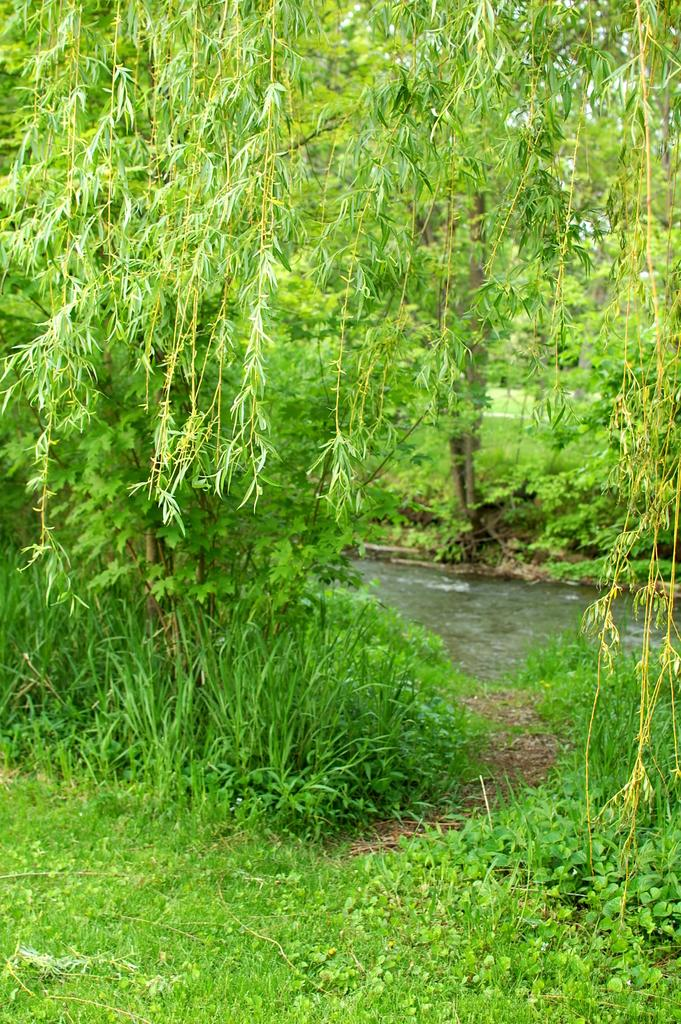What type of vegetation is present on the ground in the image? There are plants and grass on the ground in the image. Can you describe the water visible in the image? The water is visible in the image, but its specific location or amount is not mentioned. What other types of vegetation can be seen in the image? There are trees in the image. What type of stew is being prepared in the image? There is no mention of stew or any cooking activity in the image. How does the desire for water affect the plants in the image? The image does not provide information about the plants' desire for water or any emotional states. 